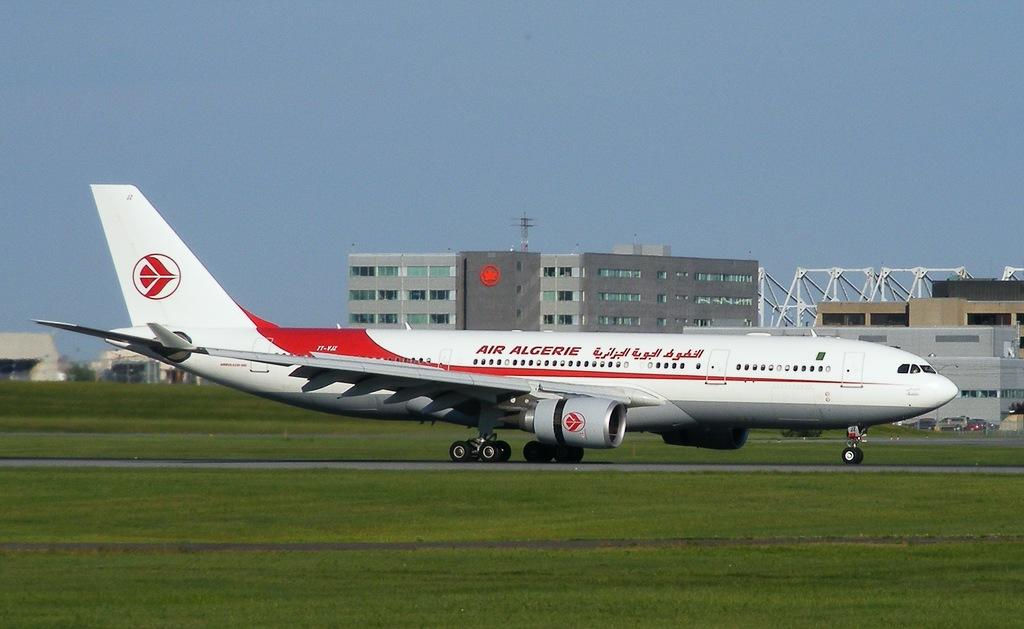What is the main subject in the center of the image? There is an airplane in the center of the image. What type of surface is visible at the bottom of the image? There is grass on the surface at the bottom of the image. What can be seen in the background of the image? There are buildings and cars in the background of the image, as well as the sky. How many cattle can be seen grazing on the grass in the image? There are no cattle present in the image; it features an airplane, grass, buildings, cars, and the sky. What type of seat is available for passengers inside the airplane in the image? The image does not show the interior of the airplane, so it is not possible to determine what type of seats are available for passengers. 